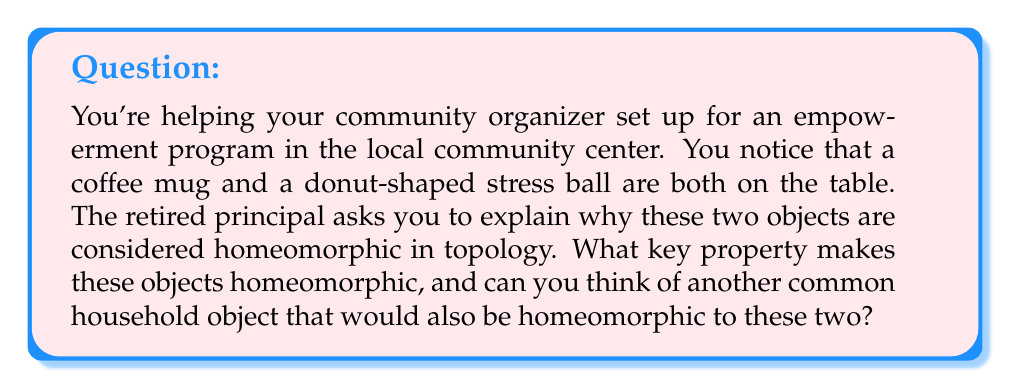Could you help me with this problem? To understand why a coffee mug and a donut-shaped stress ball are homeomorphic, we need to explore the concept of homeomorphism in topology:

1. Homeomorphism definition: Two objects are considered homeomorphic if one can be continuously deformed into the other without cutting, tearing, or gluing.

2. Key property: The most important feature that makes these objects homeomorphic is that they both have exactly one hole. In topology, this property is called the genus of the surface. Both the coffee mug and the donut-shaped stress ball have a genus of 1.

3. Continuous deformation: Imagine the coffee mug is made of a flexible material. We can continuously deform it into a donut shape by:
   a) Pushing the bottom of the mug upwards
   b) Widening the body of the mug
   c) Shrinking the handle to match the thickness of the new donut shape

4. Preserving topological properties: During this transformation, we haven't created or destroyed any holes, nor have we cut or glued any parts. The single hole (formed by the handle in the mug and the center in the donut) is preserved throughout the deformation.

5. Another homeomorphic object: A common household object that would also be homeomorphic to these two is a belt. A belt also has one hole and can be continuously deformed into either a coffee mug shape or a donut shape without changing its fundamental topological structure.

6. Mathematical representation: In topology, we can represent these surfaces using the equation:

   $$S^1 \times S^1$$

   Where $S^1$ represents a circle. This equation describes a torus, which is the formal name for the donut-shaped surface that all these objects share topologically.

Understanding homeomorphisms helps us see beyond the superficial differences in shape and focus on the fundamental topological properties that objects share.
Answer: The key property that makes a coffee mug and a donut-shaped stress ball homeomorphic is that they both have exactly one hole (genus 1). Another common household object that would be homeomorphic to these two is a belt. 